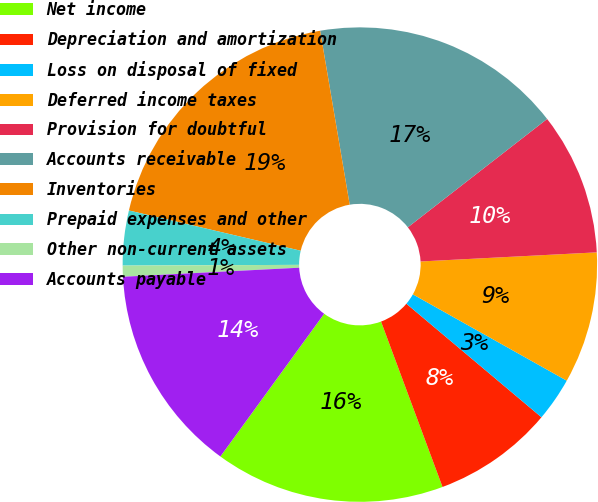Convert chart to OTSL. <chart><loc_0><loc_0><loc_500><loc_500><pie_chart><fcel>Net income<fcel>Depreciation and amortization<fcel>Loss on disposal of fixed<fcel>Deferred income taxes<fcel>Provision for doubtful<fcel>Accounts receivable<fcel>Inventories<fcel>Prepaid expenses and other<fcel>Other non-current assets<fcel>Accounts payable<nl><fcel>15.67%<fcel>8.21%<fcel>2.99%<fcel>8.96%<fcel>9.7%<fcel>17.16%<fcel>18.66%<fcel>3.73%<fcel>0.75%<fcel>14.18%<nl></chart> 